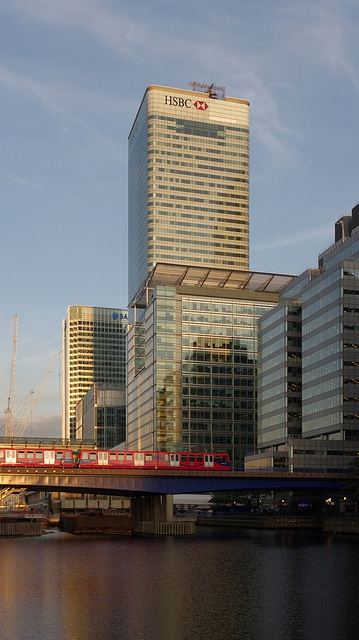Describe the objects in this image and their specific colors. I can see a train in darkgray, brown, tan, black, and maroon tones in this image. 